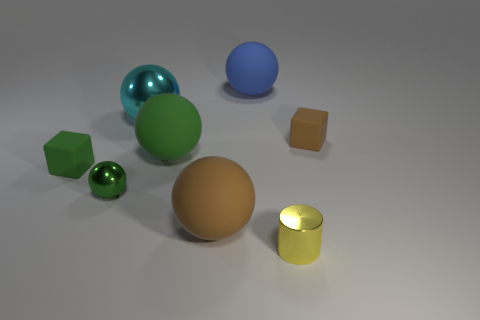Is there anything else that has the same shape as the small yellow object?
Offer a very short reply. No. What color is the tiny metal sphere?
Your answer should be very brief. Green. Is the cyan shiny thing the same size as the brown cube?
Provide a succinct answer. No. How many things are large gray matte things or yellow cylinders?
Keep it short and to the point. 1. Are there the same number of large matte spheres on the right side of the large blue sphere and tiny yellow metal cylinders?
Offer a very short reply. No. There is a tiny matte thing in front of the small rubber cube right of the large green rubber ball; are there any cyan objects that are on the left side of it?
Offer a very short reply. No. The other small object that is the same material as the small brown thing is what color?
Provide a short and direct response. Green. There is a large object that is left of the big green object; is it the same color as the small metal cylinder?
Ensure brevity in your answer.  No. What number of balls are either tiny yellow matte things or small green shiny objects?
Make the answer very short. 1. What is the size of the cube that is on the right side of the brown matte thing that is in front of the small matte thing that is to the left of the big blue matte object?
Keep it short and to the point. Small. 